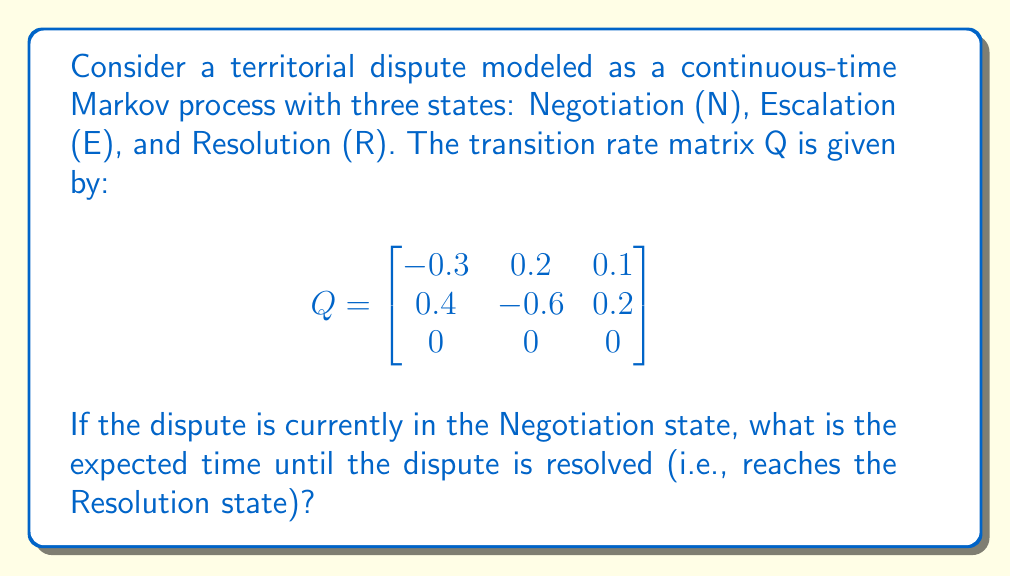Can you answer this question? To solve this problem, we'll use the theory of absorbing Markov chains:

1) First, note that the Resolution state is an absorbing state (once entered, it cannot be left).

2) We need to calculate the fundamental matrix N:
   $$N = (-Q_{T})^{-1}$$
   where $Q_{T}$ is the submatrix of Q containing only the transient states (N and E).

3) $Q_{T} = \begin{bmatrix}
   -0.3 & 0.2 \\
   0.4 & -0.6
   \end{bmatrix}$

4) Calculate $-Q_{T}$:
   $$-Q_{T} = \begin{bmatrix}
   0.3 & -0.2 \\
   -0.4 & 0.6
   \end{bmatrix}$$

5) Find $(-Q_{T})^{-1}$:
   $$N = (-Q_{T})^{-1} = \frac{1}{0.3 \cdot 0.6 - (-0.2) \cdot (-0.4)} \begin{bmatrix}
   0.6 & 0.2 \\
   0.4 & 0.3
   \end{bmatrix} = \begin{bmatrix}
   5 & \frac{5}{3} \\
   \frac{10}{3} & \frac{5}{2}
   \end{bmatrix}$$

6) The expected time to absorption (resolution) from each transient state is given by the sum of the corresponding row in N.

7) Since we start in the Negotiation state (first row), the expected time to resolution is:
   $$5 + \frac{5}{3} = \frac{20}{3} \approx 6.67$$

Therefore, the expected time until the dispute is resolved, starting from the Negotiation state, is $\frac{20}{3}$ time units.
Answer: $\frac{20}{3}$ time units 